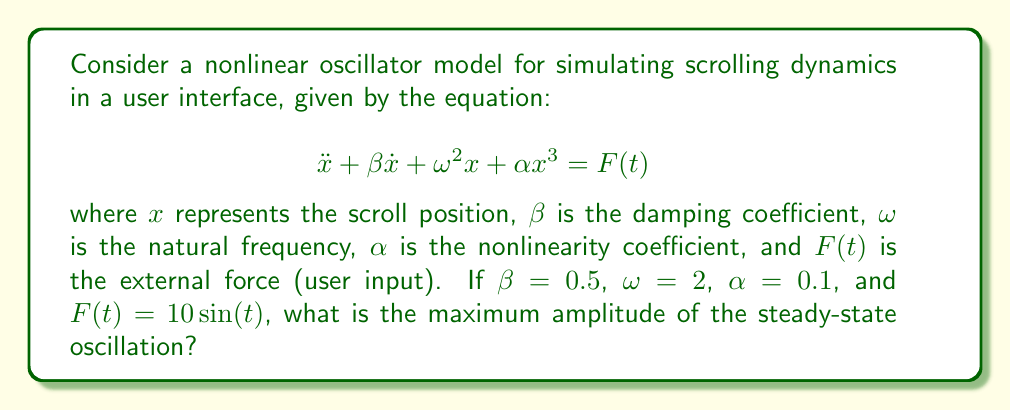Could you help me with this problem? To solve this problem, we'll follow these steps:

1) First, we recognize that this is a Duffing equation, which is a nonlinear oscillator model.

2) For small amplitudes, the nonlinear term $\alpha x^3$ has little effect, and the system behaves like a linear oscillator. However, for larger amplitudes, this term becomes significant.

3) In the steady-state, the system will oscillate at the same frequency as the forcing term, which is $\sin(t)$. So, the frequency of oscillation will be 1.

4) For a linear system, we could easily calculate the amplitude using the frequency response function. However, due to the nonlinearity, we need to use an approximation method.

5) One common method is the harmonic balance method. We assume a solution of the form:

   $$ x(t) = A\sin(t) $$

6) Substituting this into the original equation:

   $$ -A\sin(t) + 0.5A\cos(t) + 4A\sin(t) + 0.1A^3\sin^3(t) = 10\sin(t) $$

7) Using the identity $\sin^3(t) = \frac{3}{4}\sin(t) - \frac{1}{4}\sin(3t)$, and ignoring higher harmonics:

   $$ (-A + 4A + \frac{3}{4}0.1A^3)\sin(t) + 0.5A\cos(t) \approx 10\sin(t) $$

8) Equating coefficients of $\sin(t)$ and $\cos(t)$:

   $$ 3A + \frac{3}{4}0.1A^3 = 10 $$
   $$ 0.5A = 0 $$

9) The second equation is trivially satisfied. Solving the first equation:

   $$ 3A + 0.075A^3 = 10 $$
   $$ 0.075A^3 + 3A - 10 = 0 $$

10) This cubic equation can be solved numerically, giving A ≈ 2.8735.

Therefore, the maximum amplitude of the steady-state oscillation is approximately 2.8735.
Answer: 2.8735 